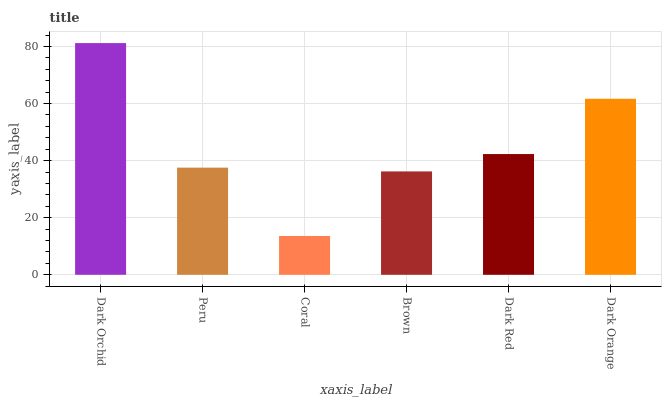Is Coral the minimum?
Answer yes or no. Yes. Is Dark Orchid the maximum?
Answer yes or no. Yes. Is Peru the minimum?
Answer yes or no. No. Is Peru the maximum?
Answer yes or no. No. Is Dark Orchid greater than Peru?
Answer yes or no. Yes. Is Peru less than Dark Orchid?
Answer yes or no. Yes. Is Peru greater than Dark Orchid?
Answer yes or no. No. Is Dark Orchid less than Peru?
Answer yes or no. No. Is Dark Red the high median?
Answer yes or no. Yes. Is Peru the low median?
Answer yes or no. Yes. Is Brown the high median?
Answer yes or no. No. Is Dark Orchid the low median?
Answer yes or no. No. 